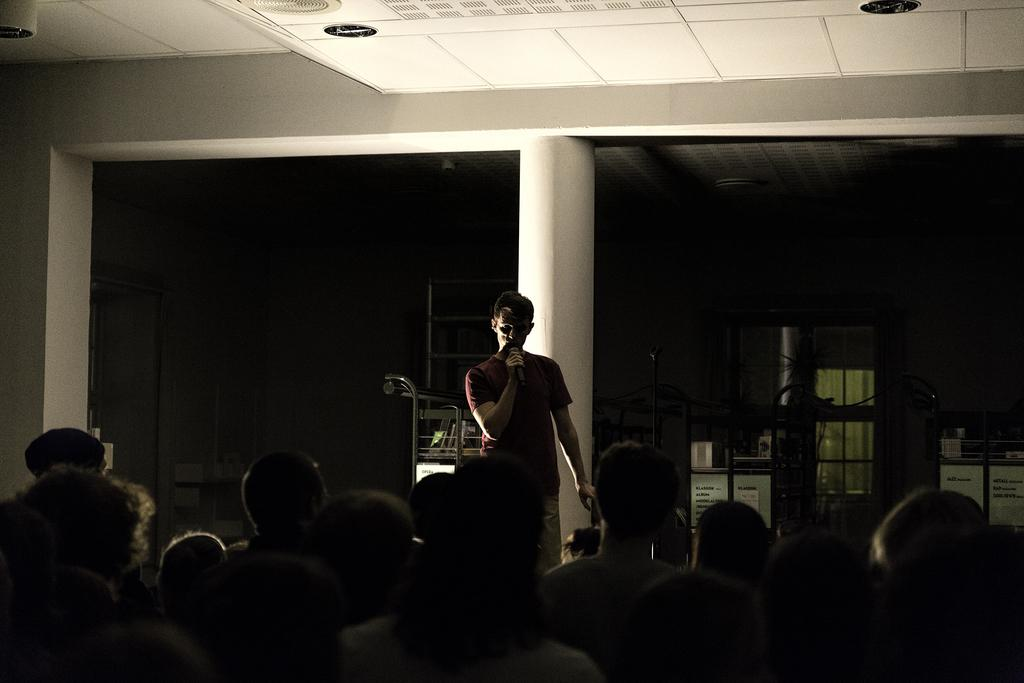How many people are in the image? There is a group of people in the image. What is one person in the group doing? One person is holding a microphone. What can be seen in the background of the image? There are pillars visible in the background of the image, as well as other objects. What type of beds can be seen in the image? There are no beds present in the image. What song is the person holding the microphone singing in the image? The image does not provide any information about the song being sung by the person holding the microphone. 